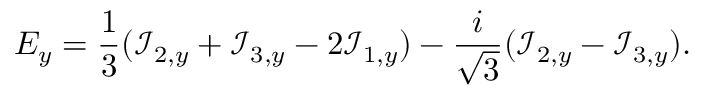<formula> <loc_0><loc_0><loc_500><loc_500>E _ { y } = \frac { 1 } { 3 } ( \mathcal { I } _ { 2 , y } + \mathcal { I } _ { 3 , y } - 2 \mathcal { I } _ { 1 , y } ) - \frac { i } { \sqrt { 3 } } ( \mathcal { I } _ { 2 , y } - \mathcal { I } _ { 3 , y } ) .</formula> 